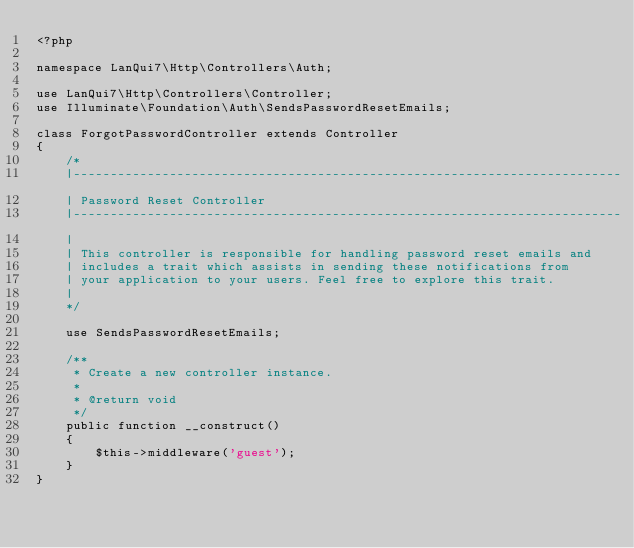Convert code to text. <code><loc_0><loc_0><loc_500><loc_500><_PHP_><?php

namespace LanQui7\Http\Controllers\Auth;

use LanQui7\Http\Controllers\Controller;
use Illuminate\Foundation\Auth\SendsPasswordResetEmails;

class ForgotPasswordController extends Controller
{
    /*
    |--------------------------------------------------------------------------
    | Password Reset Controller
    |--------------------------------------------------------------------------
    |
    | This controller is responsible for handling password reset emails and
    | includes a trait which assists in sending these notifications from
    | your application to your users. Feel free to explore this trait.
    |
    */

    use SendsPasswordResetEmails;

    /**
     * Create a new controller instance.
     *
     * @return void
     */
    public function __construct()
    {
        $this->middleware('guest');
    }
}
</code> 